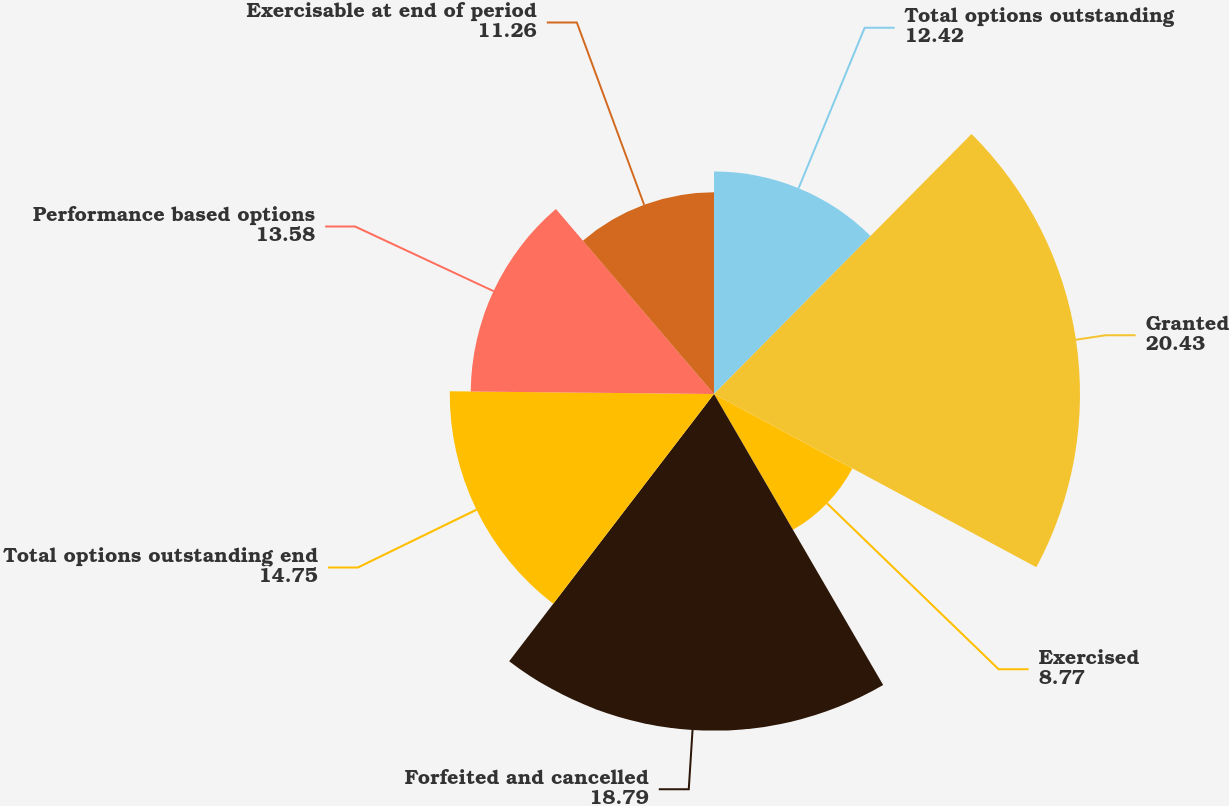Convert chart to OTSL. <chart><loc_0><loc_0><loc_500><loc_500><pie_chart><fcel>Total options outstanding<fcel>Granted<fcel>Exercised<fcel>Forfeited and cancelled<fcel>Total options outstanding end<fcel>Performance based options<fcel>Exercisable at end of period<nl><fcel>12.42%<fcel>20.43%<fcel>8.77%<fcel>18.79%<fcel>14.75%<fcel>13.58%<fcel>11.26%<nl></chart> 